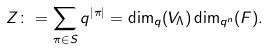<formula> <loc_0><loc_0><loc_500><loc_500>Z \colon = \sum _ { \pi \in S } q ^ { | \pi | } = \dim _ { q } ( V _ { \Lambda } ) \dim _ { q ^ { n } } ( F ) .</formula> 